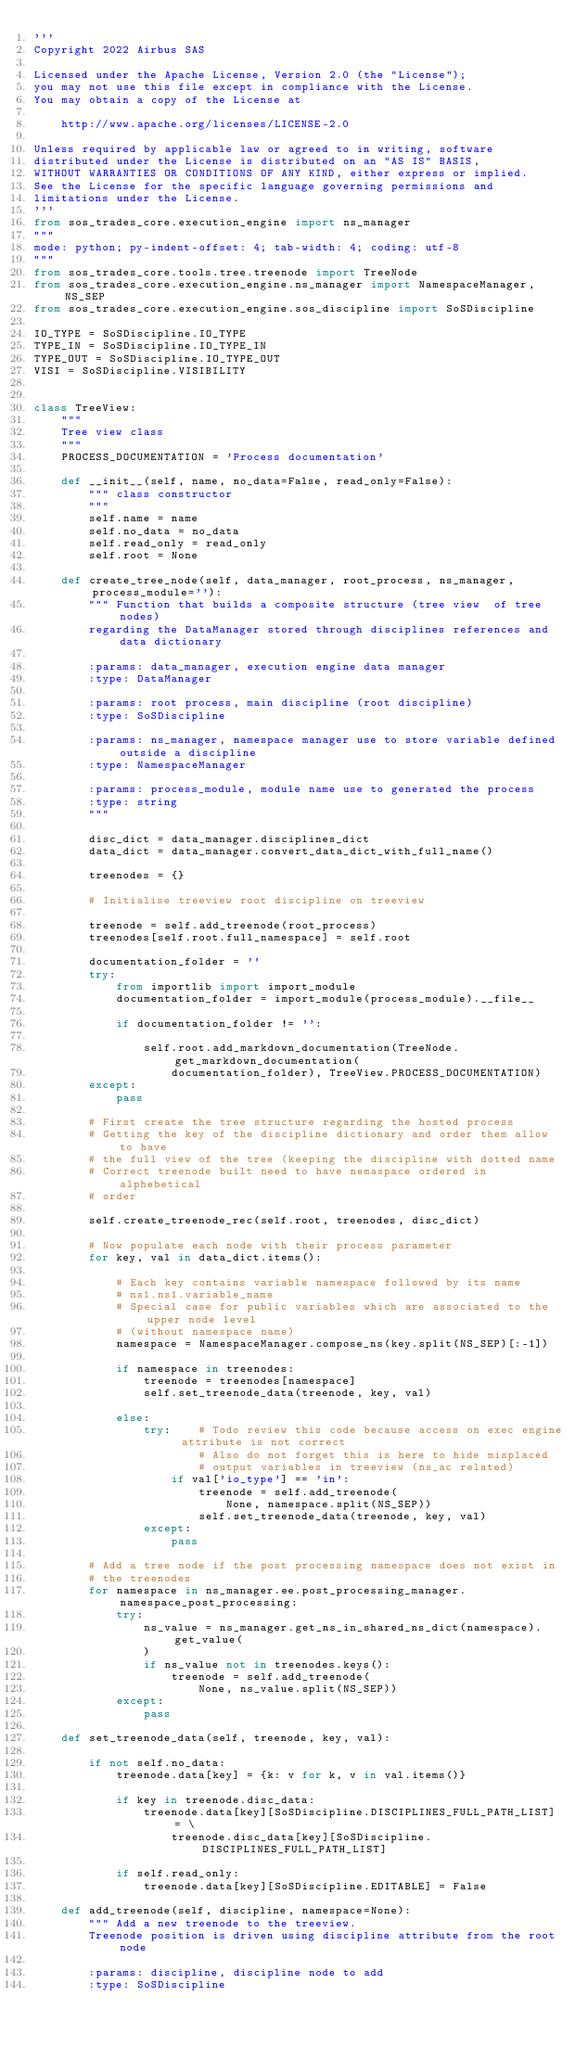<code> <loc_0><loc_0><loc_500><loc_500><_Python_>'''
Copyright 2022 Airbus SAS

Licensed under the Apache License, Version 2.0 (the "License");
you may not use this file except in compliance with the License.
You may obtain a copy of the License at

    http://www.apache.org/licenses/LICENSE-2.0

Unless required by applicable law or agreed to in writing, software
distributed under the License is distributed on an "AS IS" BASIS,
WITHOUT WARRANTIES OR CONDITIONS OF ANY KIND, either express or implied.
See the License for the specific language governing permissions and
limitations under the License.
'''
from sos_trades_core.execution_engine import ns_manager
"""
mode: python; py-indent-offset: 4; tab-width: 4; coding: utf-8
"""
from sos_trades_core.tools.tree.treenode import TreeNode
from sos_trades_core.execution_engine.ns_manager import NamespaceManager, NS_SEP
from sos_trades_core.execution_engine.sos_discipline import SoSDiscipline

IO_TYPE = SoSDiscipline.IO_TYPE
TYPE_IN = SoSDiscipline.IO_TYPE_IN
TYPE_OUT = SoSDiscipline.IO_TYPE_OUT
VISI = SoSDiscipline.VISIBILITY


class TreeView:
    """
    Tree view class
    """
    PROCESS_DOCUMENTATION = 'Process documentation'

    def __init__(self, name, no_data=False, read_only=False):
        """ class constructor
        """
        self.name = name
        self.no_data = no_data
        self.read_only = read_only
        self.root = None

    def create_tree_node(self, data_manager, root_process, ns_manager, process_module=''):
        """ Function that builds a composite structure (tree view  of tree nodes)
        regarding the DataManager stored through disciplines references and data dictionary

        :params: data_manager, execution engine data manager
        :type: DataManager

        :params: root process, main discipline (root discipline)
        :type: SoSDiscipline

        :params: ns_manager, namespace manager use to store variable defined outside a discipline
        :type: NamespaceManager

        :params: process_module, module name use to generated the process
        :type: string
        """

        disc_dict = data_manager.disciplines_dict
        data_dict = data_manager.convert_data_dict_with_full_name()

        treenodes = {}

        # Initialise treeview root discipline on treeview

        treenode = self.add_treenode(root_process)
        treenodes[self.root.full_namespace] = self.root

        documentation_folder = ''
        try:
            from importlib import import_module
            documentation_folder = import_module(process_module).__file__

            if documentation_folder != '':

                self.root.add_markdown_documentation(TreeNode.get_markdown_documentation(
                    documentation_folder), TreeView.PROCESS_DOCUMENTATION)
        except:
            pass

        # First create the tree structure regarding the hosted process
        # Getting the key of the discipline dictionary and order them allow to have
        # the full view of the tree (keeping the discipline with dotted name
        # Correct treenode built need to have nemaspace ordered in alphebetical
        # order

        self.create_treenode_rec(self.root, treenodes, disc_dict)

        # Now populate each node with their process parameter
        for key, val in data_dict.items():

            # Each key contains variable namespace followed by its name
            # ns1.ns1.variable_name
            # Special case for public variables which are associated to the upper node level
            # (without namespace name)
            namespace = NamespaceManager.compose_ns(key.split(NS_SEP)[:-1])

            if namespace in treenodes:
                treenode = treenodes[namespace]
                self.set_treenode_data(treenode, key, val)

            else:
                try:    # Todo review this code because access on exec engine attribute is not correct
                        # Also do not forget this is here to hide misplaced
                        # output variables in treeview (ns_ac related)
                    if val['io_type'] == 'in':
                        treenode = self.add_treenode(
                            None, namespace.split(NS_SEP))
                        self.set_treenode_data(treenode, key, val)
                except:
                    pass

        # Add a tree node if the post processing namespace does not exist in
        # the treenodes
        for namespace in ns_manager.ee.post_processing_manager.namespace_post_processing:
            try:
                ns_value = ns_manager.get_ns_in_shared_ns_dict(namespace).get_value(
                )
                if ns_value not in treenodes.keys():
                    treenode = self.add_treenode(
                        None, ns_value.split(NS_SEP))
            except:
                pass

    def set_treenode_data(self, treenode, key, val):

        if not self.no_data:
            treenode.data[key] = {k: v for k, v in val.items()}

            if key in treenode.disc_data:
                treenode.data[key][SoSDiscipline.DISCIPLINES_FULL_PATH_LIST] = \
                    treenode.disc_data[key][SoSDiscipline.DISCIPLINES_FULL_PATH_LIST]

            if self.read_only:
                treenode.data[key][SoSDiscipline.EDITABLE] = False

    def add_treenode(self, discipline, namespace=None):
        """ Add a new treenode to the treeview.
        Treenode position is driven using discipline attribute from the root node

        :params: discipline, discipline node to add
        :type: SoSDiscipline
</code> 